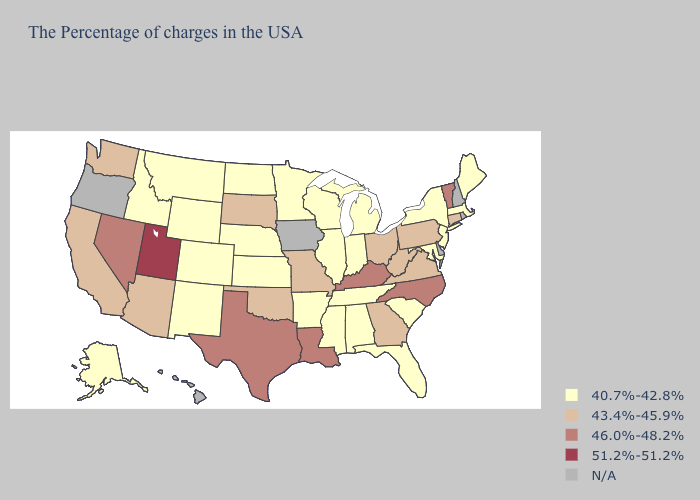What is the value of Florida?
Be succinct. 40.7%-42.8%. Among the states that border Utah , which have the highest value?
Keep it brief. Nevada. What is the value of Michigan?
Give a very brief answer. 40.7%-42.8%. What is the value of Oklahoma?
Short answer required. 43.4%-45.9%. What is the value of West Virginia?
Write a very short answer. 43.4%-45.9%. What is the value of Alaska?
Give a very brief answer. 40.7%-42.8%. Name the states that have a value in the range N/A?
Be succinct. Rhode Island, New Hampshire, Delaware, Iowa, Oregon, Hawaii. Which states have the lowest value in the Northeast?
Quick response, please. Maine, Massachusetts, New York, New Jersey. Which states have the highest value in the USA?
Short answer required. Utah. What is the highest value in the USA?
Concise answer only. 51.2%-51.2%. Name the states that have a value in the range N/A?
Be succinct. Rhode Island, New Hampshire, Delaware, Iowa, Oregon, Hawaii. What is the highest value in the MidWest ?
Quick response, please. 43.4%-45.9%. Name the states that have a value in the range 46.0%-48.2%?
Short answer required. Vermont, North Carolina, Kentucky, Louisiana, Texas, Nevada. 